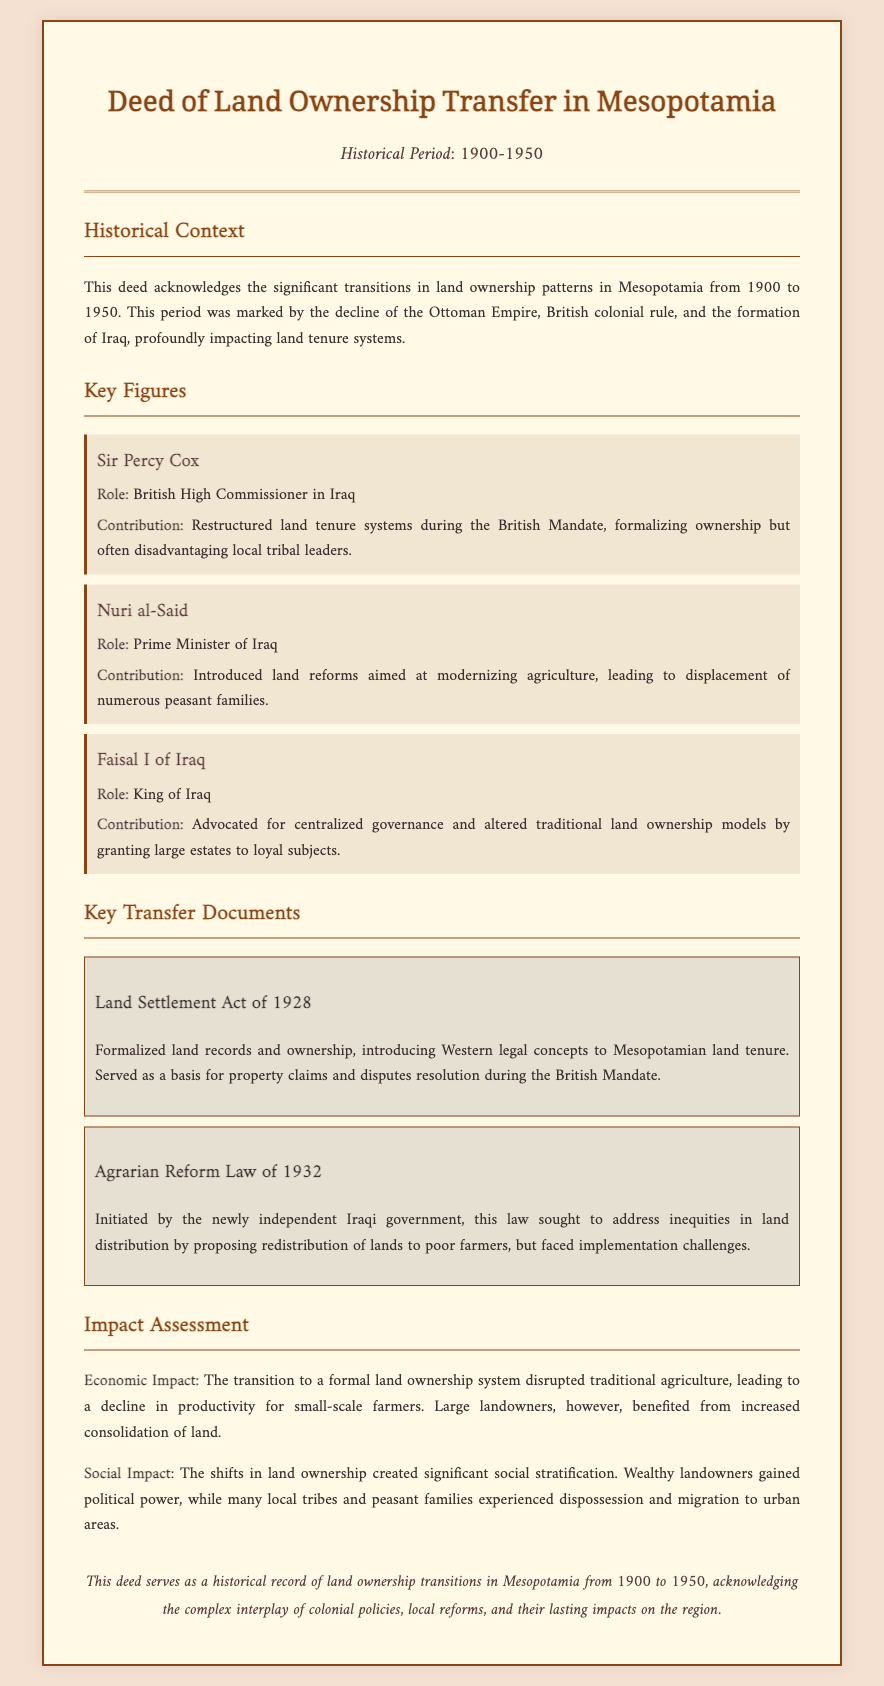what time frame does the deed cover? The deed includes the historical period from 1900 to 1950, marking significant transitions in land ownership in Mesopotamia.
Answer: 1900-1950 who was the British High Commissioner in Iraq? The document names Sir Percy Cox as the British High Commissioner in Iraq during the relevant historical period.
Answer: Sir Percy Cox what was a key document related to land ownership in 1928? The deed references the Land Settlement Act of 1928, which formalized land records and ownership.
Answer: Land Settlement Act of 1928 what is one impact of the transition to formal land ownership? The document notes that the transition disrupted traditional agriculture, leading to a decline in productivity for small-scale farmers.
Answer: Decline in productivity who introduced land reforms aimed at modernizing agriculture? The deed identifies Nuri al-Said as the individual who introduced land reforms in Iraq.
Answer: Nuri al-Said what was the purpose of the Agrarian Reform Law of 1932? The law aimed to address inequities in land distribution by proposing the redistribution of lands to poor farmers.
Answer: Redistribute lands what role did Faisal I of Iraq play in land ownership transitions? Faisal I advocated for centralized governance and altered traditional land ownership models during his reign.
Answer: Centralized governance what type of impact does the deed discuss regarding land ownership transitions? The document assesses both economic and social impacts resulting from changes in land ownership patterns.
Answer: Economic and social impact who advocated for granting large estates to loyal subjects? The deed attributes the action of granting large estates to Faisal I of Iraq.
Answer: Faisal I of Iraq 